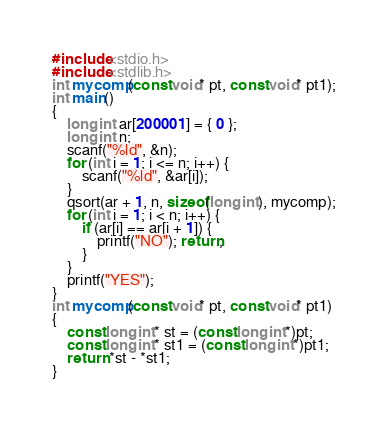Convert code to text. <code><loc_0><loc_0><loc_500><loc_500><_C_>#include<stdio.h>
#include<stdlib.h>
int mycomp(const void* pt, const void* pt1);
int main()
{
	long int ar[200001] = { 0 };
	long int n;
	scanf("%ld", &n);
	for (int i = 1; i <= n; i++) {
		scanf("%ld", &ar[i]);
	}
	qsort(ar + 1, n, sizeof(long int), mycomp);
	for (int i = 1; i < n; i++) {
		if (ar[i] == ar[i + 1]) {
			printf("NO"); return;
		}
	}
	printf("YES");
}
int mycomp(const void* pt, const void* pt1)
{
	const long int* st = (const long int*)pt;
	const long int* st1 = (const long int*)pt1;
	return *st - *st1;
}</code> 